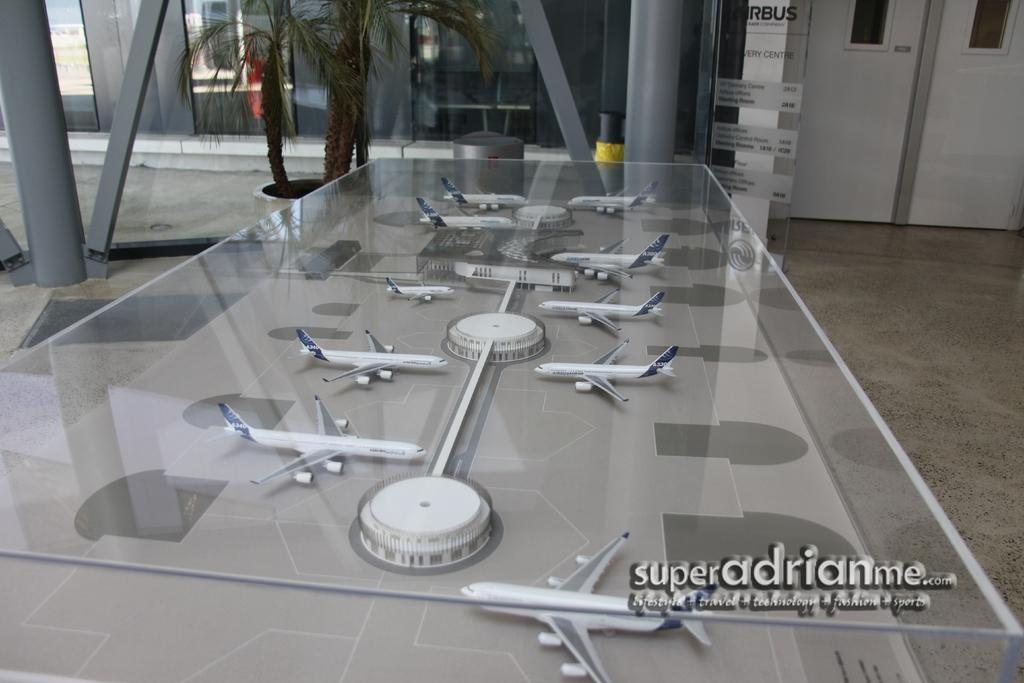What objects are inside the glass table in the image? There are aeroplanes inside a glass table in the image. What can be seen near the glass table? There is a door visible in the image. What is the purpose of the bin in the image? The bin is likely for waste disposal. What type of vegetation is present in the image? There are plants in the image. What type of meat is being prepared in the garden in the image? There is no garden or meat preparation visible in the image. 